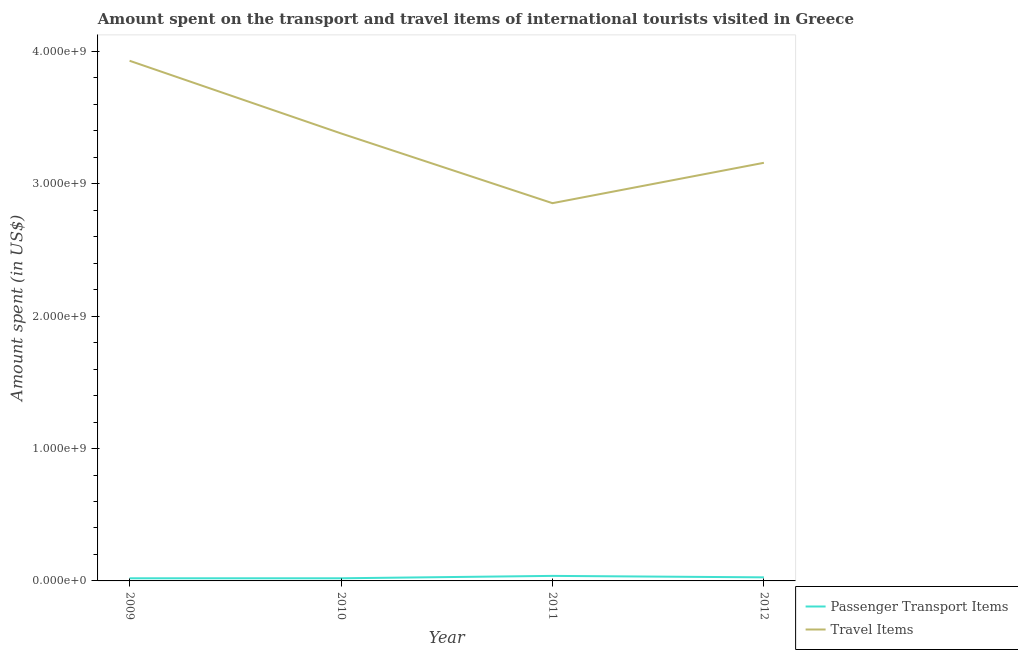How many different coloured lines are there?
Your answer should be very brief. 2. Is the number of lines equal to the number of legend labels?
Give a very brief answer. Yes. What is the amount spent on passenger transport items in 2010?
Your answer should be compact. 2.00e+07. Across all years, what is the maximum amount spent in travel items?
Your response must be concise. 3.93e+09. Across all years, what is the minimum amount spent in travel items?
Your answer should be compact. 2.85e+09. What is the total amount spent in travel items in the graph?
Give a very brief answer. 1.33e+1. What is the difference between the amount spent in travel items in 2009 and that in 2012?
Offer a terse response. 7.71e+08. What is the difference between the amount spent on passenger transport items in 2011 and the amount spent in travel items in 2009?
Offer a very short reply. -3.89e+09. What is the average amount spent on passenger transport items per year?
Your answer should be compact. 2.62e+07. In the year 2009, what is the difference between the amount spent in travel items and amount spent on passenger transport items?
Your response must be concise. 3.91e+09. In how many years, is the amount spent on passenger transport items greater than 1800000000 US$?
Your response must be concise. 0. What is the ratio of the amount spent on passenger transport items in 2010 to that in 2011?
Keep it short and to the point. 0.53. Is the amount spent in travel items in 2011 less than that in 2012?
Provide a short and direct response. Yes. Is the difference between the amount spent in travel items in 2010 and 2012 greater than the difference between the amount spent on passenger transport items in 2010 and 2012?
Give a very brief answer. Yes. What is the difference between the highest and the second highest amount spent on passenger transport items?
Make the answer very short. 1.10e+07. What is the difference between the highest and the lowest amount spent on passenger transport items?
Ensure brevity in your answer.  1.80e+07. Does the amount spent in travel items monotonically increase over the years?
Make the answer very short. No. Is the amount spent in travel items strictly greater than the amount spent on passenger transport items over the years?
Offer a very short reply. Yes. Is the amount spent in travel items strictly less than the amount spent on passenger transport items over the years?
Your response must be concise. No. How many years are there in the graph?
Offer a terse response. 4. What is the difference between two consecutive major ticks on the Y-axis?
Offer a very short reply. 1.00e+09. Are the values on the major ticks of Y-axis written in scientific E-notation?
Provide a short and direct response. Yes. Where does the legend appear in the graph?
Provide a succinct answer. Bottom right. What is the title of the graph?
Make the answer very short. Amount spent on the transport and travel items of international tourists visited in Greece. What is the label or title of the X-axis?
Offer a terse response. Year. What is the label or title of the Y-axis?
Your answer should be very brief. Amount spent (in US$). What is the Amount spent (in US$) in Travel Items in 2009?
Your answer should be compact. 3.93e+09. What is the Amount spent (in US$) in Passenger Transport Items in 2010?
Offer a very short reply. 2.00e+07. What is the Amount spent (in US$) in Travel Items in 2010?
Keep it short and to the point. 3.38e+09. What is the Amount spent (in US$) of Passenger Transport Items in 2011?
Ensure brevity in your answer.  3.80e+07. What is the Amount spent (in US$) in Travel Items in 2011?
Give a very brief answer. 2.85e+09. What is the Amount spent (in US$) in Passenger Transport Items in 2012?
Offer a very short reply. 2.70e+07. What is the Amount spent (in US$) in Travel Items in 2012?
Ensure brevity in your answer.  3.16e+09. Across all years, what is the maximum Amount spent (in US$) of Passenger Transport Items?
Provide a short and direct response. 3.80e+07. Across all years, what is the maximum Amount spent (in US$) in Travel Items?
Provide a succinct answer. 3.93e+09. Across all years, what is the minimum Amount spent (in US$) in Travel Items?
Ensure brevity in your answer.  2.85e+09. What is the total Amount spent (in US$) in Passenger Transport Items in the graph?
Offer a very short reply. 1.05e+08. What is the total Amount spent (in US$) in Travel Items in the graph?
Provide a short and direct response. 1.33e+1. What is the difference between the Amount spent (in US$) of Passenger Transport Items in 2009 and that in 2010?
Ensure brevity in your answer.  0. What is the difference between the Amount spent (in US$) of Travel Items in 2009 and that in 2010?
Your answer should be compact. 5.49e+08. What is the difference between the Amount spent (in US$) in Passenger Transport Items in 2009 and that in 2011?
Provide a succinct answer. -1.80e+07. What is the difference between the Amount spent (in US$) in Travel Items in 2009 and that in 2011?
Your response must be concise. 1.08e+09. What is the difference between the Amount spent (in US$) in Passenger Transport Items in 2009 and that in 2012?
Your answer should be very brief. -7.00e+06. What is the difference between the Amount spent (in US$) in Travel Items in 2009 and that in 2012?
Your answer should be compact. 7.71e+08. What is the difference between the Amount spent (in US$) in Passenger Transport Items in 2010 and that in 2011?
Offer a terse response. -1.80e+07. What is the difference between the Amount spent (in US$) in Travel Items in 2010 and that in 2011?
Offer a very short reply. 5.27e+08. What is the difference between the Amount spent (in US$) of Passenger Transport Items in 2010 and that in 2012?
Your response must be concise. -7.00e+06. What is the difference between the Amount spent (in US$) of Travel Items in 2010 and that in 2012?
Your answer should be very brief. 2.22e+08. What is the difference between the Amount spent (in US$) in Passenger Transport Items in 2011 and that in 2012?
Your answer should be very brief. 1.10e+07. What is the difference between the Amount spent (in US$) in Travel Items in 2011 and that in 2012?
Offer a terse response. -3.05e+08. What is the difference between the Amount spent (in US$) of Passenger Transport Items in 2009 and the Amount spent (in US$) of Travel Items in 2010?
Offer a terse response. -3.36e+09. What is the difference between the Amount spent (in US$) of Passenger Transport Items in 2009 and the Amount spent (in US$) of Travel Items in 2011?
Keep it short and to the point. -2.83e+09. What is the difference between the Amount spent (in US$) in Passenger Transport Items in 2009 and the Amount spent (in US$) in Travel Items in 2012?
Your answer should be very brief. -3.14e+09. What is the difference between the Amount spent (in US$) in Passenger Transport Items in 2010 and the Amount spent (in US$) in Travel Items in 2011?
Provide a succinct answer. -2.83e+09. What is the difference between the Amount spent (in US$) in Passenger Transport Items in 2010 and the Amount spent (in US$) in Travel Items in 2012?
Your response must be concise. -3.14e+09. What is the difference between the Amount spent (in US$) in Passenger Transport Items in 2011 and the Amount spent (in US$) in Travel Items in 2012?
Offer a terse response. -3.12e+09. What is the average Amount spent (in US$) of Passenger Transport Items per year?
Offer a terse response. 2.62e+07. What is the average Amount spent (in US$) in Travel Items per year?
Make the answer very short. 3.33e+09. In the year 2009, what is the difference between the Amount spent (in US$) in Passenger Transport Items and Amount spent (in US$) in Travel Items?
Keep it short and to the point. -3.91e+09. In the year 2010, what is the difference between the Amount spent (in US$) of Passenger Transport Items and Amount spent (in US$) of Travel Items?
Offer a very short reply. -3.36e+09. In the year 2011, what is the difference between the Amount spent (in US$) of Passenger Transport Items and Amount spent (in US$) of Travel Items?
Your answer should be compact. -2.82e+09. In the year 2012, what is the difference between the Amount spent (in US$) in Passenger Transport Items and Amount spent (in US$) in Travel Items?
Your answer should be very brief. -3.13e+09. What is the ratio of the Amount spent (in US$) in Passenger Transport Items in 2009 to that in 2010?
Make the answer very short. 1. What is the ratio of the Amount spent (in US$) in Travel Items in 2009 to that in 2010?
Your response must be concise. 1.16. What is the ratio of the Amount spent (in US$) in Passenger Transport Items in 2009 to that in 2011?
Give a very brief answer. 0.53. What is the ratio of the Amount spent (in US$) of Travel Items in 2009 to that in 2011?
Your answer should be compact. 1.38. What is the ratio of the Amount spent (in US$) in Passenger Transport Items in 2009 to that in 2012?
Offer a terse response. 0.74. What is the ratio of the Amount spent (in US$) in Travel Items in 2009 to that in 2012?
Ensure brevity in your answer.  1.24. What is the ratio of the Amount spent (in US$) in Passenger Transport Items in 2010 to that in 2011?
Make the answer very short. 0.53. What is the ratio of the Amount spent (in US$) of Travel Items in 2010 to that in 2011?
Provide a short and direct response. 1.18. What is the ratio of the Amount spent (in US$) in Passenger Transport Items in 2010 to that in 2012?
Your response must be concise. 0.74. What is the ratio of the Amount spent (in US$) of Travel Items in 2010 to that in 2012?
Ensure brevity in your answer.  1.07. What is the ratio of the Amount spent (in US$) of Passenger Transport Items in 2011 to that in 2012?
Keep it short and to the point. 1.41. What is the ratio of the Amount spent (in US$) in Travel Items in 2011 to that in 2012?
Your answer should be compact. 0.9. What is the difference between the highest and the second highest Amount spent (in US$) in Passenger Transport Items?
Ensure brevity in your answer.  1.10e+07. What is the difference between the highest and the second highest Amount spent (in US$) of Travel Items?
Give a very brief answer. 5.49e+08. What is the difference between the highest and the lowest Amount spent (in US$) in Passenger Transport Items?
Your response must be concise. 1.80e+07. What is the difference between the highest and the lowest Amount spent (in US$) of Travel Items?
Offer a terse response. 1.08e+09. 